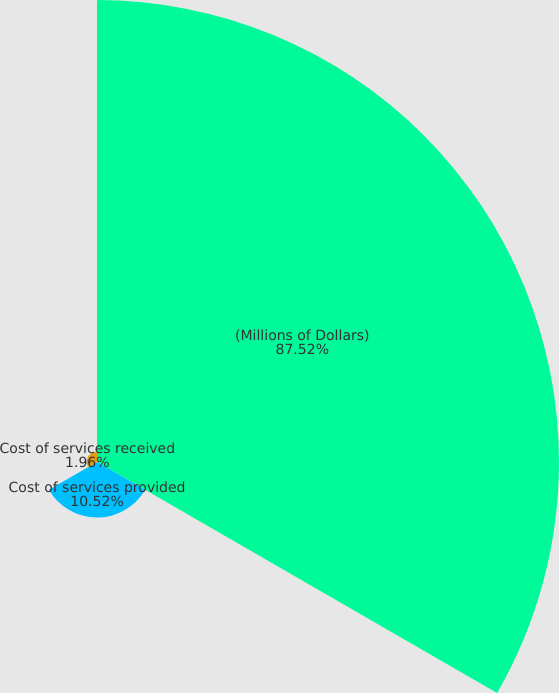<chart> <loc_0><loc_0><loc_500><loc_500><pie_chart><fcel>(Millions of Dollars)<fcel>Cost of services provided<fcel>Cost of services received<nl><fcel>87.52%<fcel>10.52%<fcel>1.96%<nl></chart> 